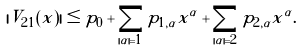<formula> <loc_0><loc_0><loc_500><loc_500>| V _ { 2 1 } ( x ) | \leq p _ { 0 } + \sum _ { | \alpha | = 1 } p _ { 1 , \alpha } x ^ { \alpha } + \sum _ { | \alpha | = 2 } p _ { 2 , \alpha } x ^ { \alpha } .</formula> 